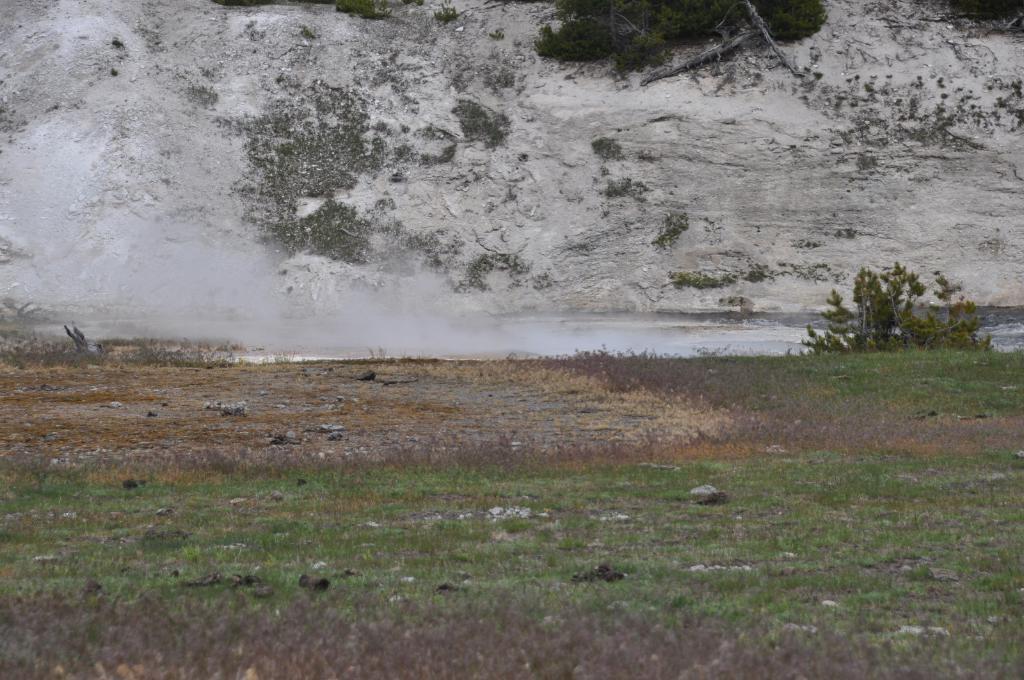Could you give a brief overview of what you see in this image? In the foreground we can see the grass. Here we can see the stones on the ground. Here we can see the smoke. Here we can see small plants on the right side. This is looking like a mountain. 